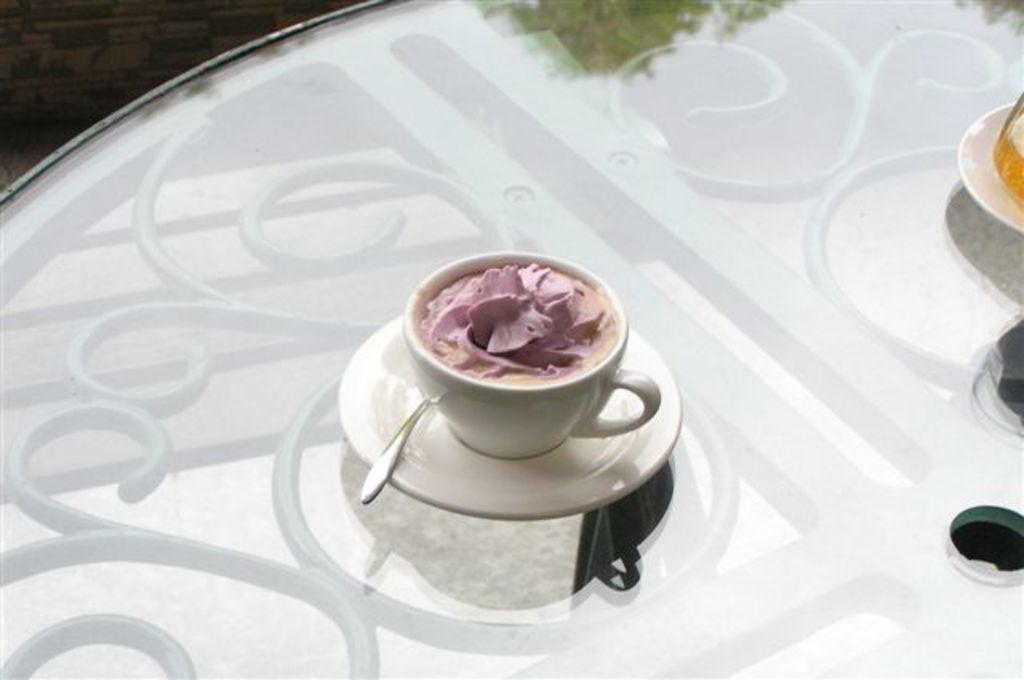Could you give a brief overview of what you see in this image? It's an ice cream in a cup on the table 